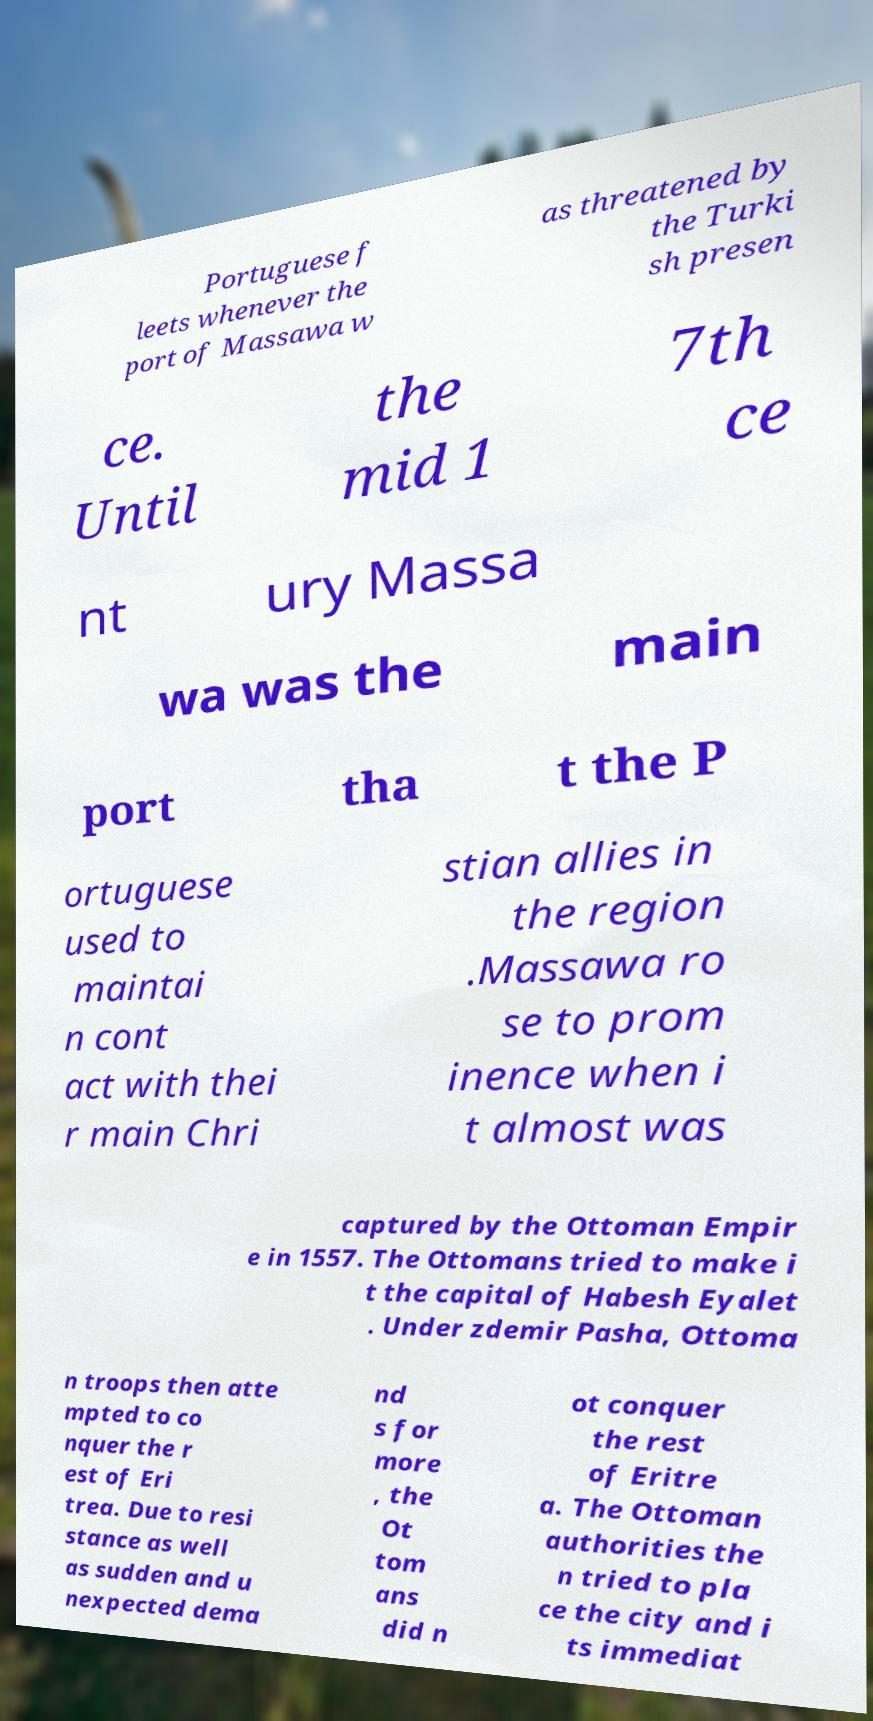Please read and relay the text visible in this image. What does it say? Portuguese f leets whenever the port of Massawa w as threatened by the Turki sh presen ce. Until the mid 1 7th ce nt ury Massa wa was the main port tha t the P ortuguese used to maintai n cont act with thei r main Chri stian allies in the region .Massawa ro se to prom inence when i t almost was captured by the Ottoman Empir e in 1557. The Ottomans tried to make i t the capital of Habesh Eyalet . Under zdemir Pasha, Ottoma n troops then atte mpted to co nquer the r est of Eri trea. Due to resi stance as well as sudden and u nexpected dema nd s for more , the Ot tom ans did n ot conquer the rest of Eritre a. The Ottoman authorities the n tried to pla ce the city and i ts immediat 